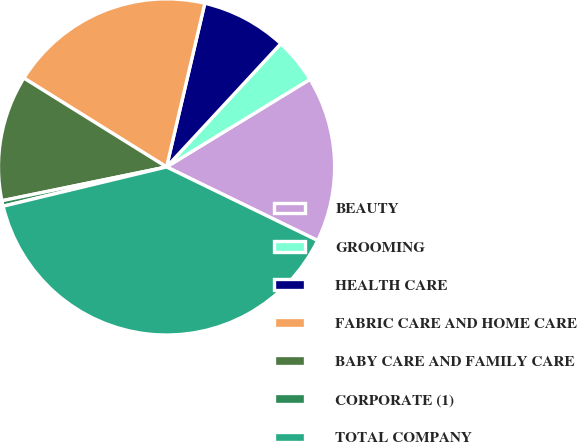Convert chart. <chart><loc_0><loc_0><loc_500><loc_500><pie_chart><fcel>BEAUTY<fcel>GROOMING<fcel>HEALTH CARE<fcel>FABRIC CARE AND HOME CARE<fcel>BABY CARE AND FAMILY CARE<fcel>CORPORATE (1)<fcel>TOTAL COMPANY<nl><fcel>15.94%<fcel>4.38%<fcel>8.24%<fcel>19.79%<fcel>12.09%<fcel>0.53%<fcel>39.04%<nl></chart> 